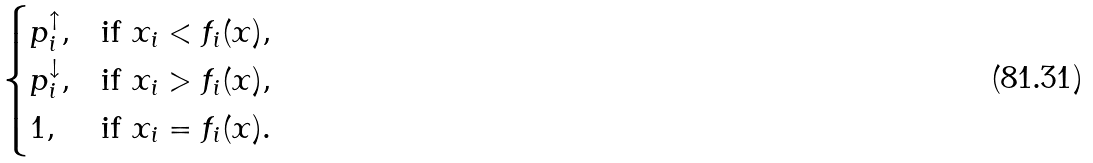Convert formula to latex. <formula><loc_0><loc_0><loc_500><loc_500>\begin{cases} p _ { i } ^ { \uparrow } , & \text {if $x_{i}<f_{i}(x)$} , \\ p _ { i } ^ { \downarrow } , & \text {if $x_{i}>f_{i}(x)$} , \\ 1 , & \text {if $x_{i}=f_{i}(x)$} . \end{cases}</formula> 